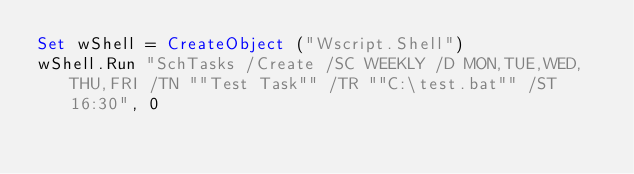<code> <loc_0><loc_0><loc_500><loc_500><_VisualBasic_>Set wShell = CreateObject ("Wscript.Shell")
wShell.Run "SchTasks /Create /SC WEEKLY /D MON,TUE,WED,THU,FRI /TN ""Test Task"" /TR ""C:\test.bat"" /ST 16:30", 0</code> 